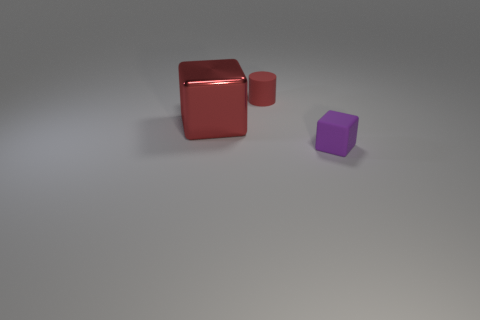The tiny block has what color?
Your answer should be very brief. Purple. How many tiny objects are red rubber cylinders or yellow things?
Your answer should be compact. 1. What is the material of the cube that is the same color as the small matte cylinder?
Offer a terse response. Metal. Do the tiny object that is behind the tiny matte block and the block behind the small purple rubber cube have the same material?
Ensure brevity in your answer.  No. Are there any large red cubes?
Keep it short and to the point. Yes. Is the number of red matte things on the left side of the red metal thing greater than the number of cylinders that are in front of the red matte thing?
Offer a terse response. No. What material is the other object that is the same shape as the purple object?
Keep it short and to the point. Metal. Is there any other thing that has the same size as the purple block?
Offer a terse response. Yes. Does the matte object that is behind the big shiny block have the same color as the matte thing in front of the large red object?
Give a very brief answer. No. What shape is the red rubber thing?
Offer a very short reply. Cylinder. 